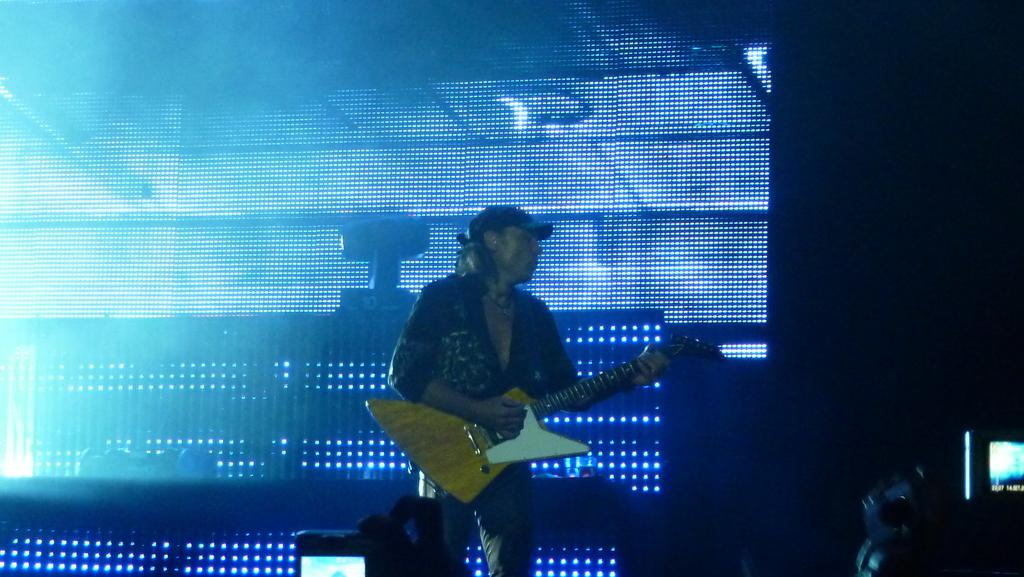What is the person in the image doing? The person is playing a guitar. What is the person wearing on their head? The person is wearing a cap. What can be seen in the background of the image? There are colorful lights in the background of the image. Is the person skating on ice while playing the guitar in the image? No, there is no ice or skating depicted in the image; the person is playing the guitar while standing. 